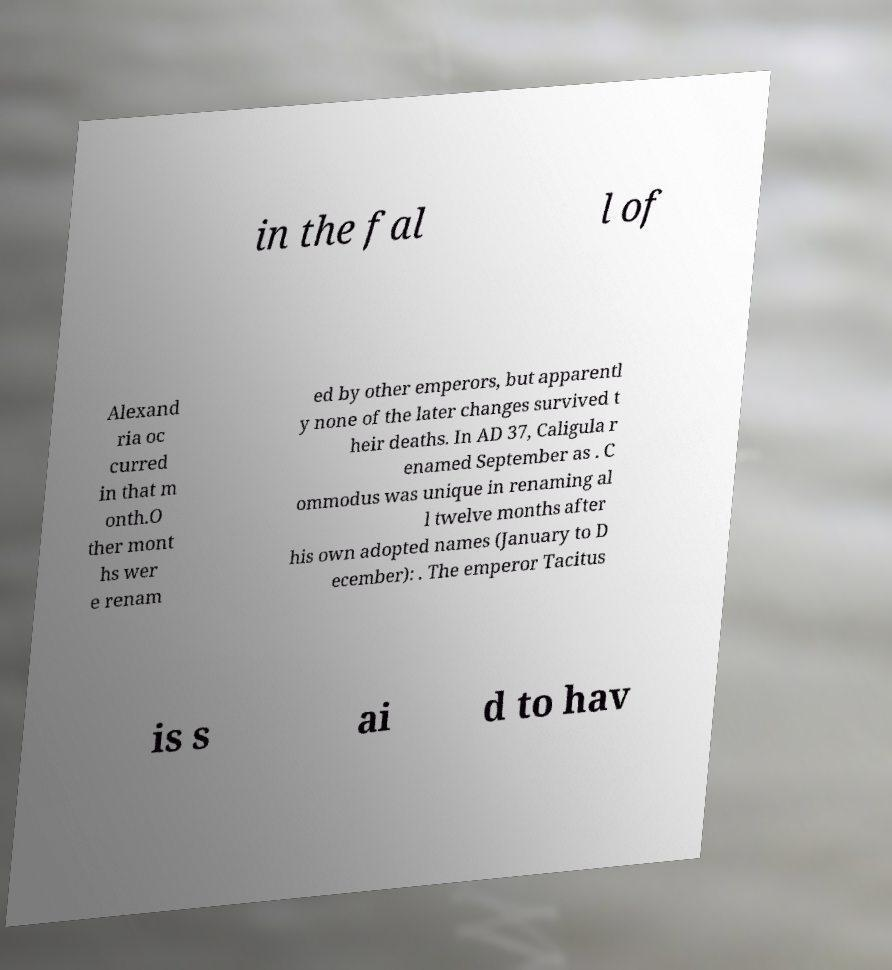What messages or text are displayed in this image? I need them in a readable, typed format. in the fal l of Alexand ria oc curred in that m onth.O ther mont hs wer e renam ed by other emperors, but apparentl y none of the later changes survived t heir deaths. In AD 37, Caligula r enamed September as . C ommodus was unique in renaming al l twelve months after his own adopted names (January to D ecember): . The emperor Tacitus is s ai d to hav 